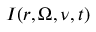<formula> <loc_0><loc_0><loc_500><loc_500>I ( r , \Omega , \nu , t )</formula> 